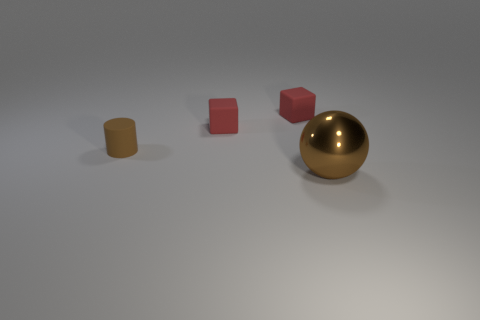Add 3 big brown cylinders. How many objects exist? 7 Subtract all cylinders. How many objects are left? 3 Add 2 red matte things. How many red matte things are left? 4 Add 4 red rubber cubes. How many red rubber cubes exist? 6 Subtract 0 red balls. How many objects are left? 4 Subtract all cyan rubber blocks. Subtract all red blocks. How many objects are left? 2 